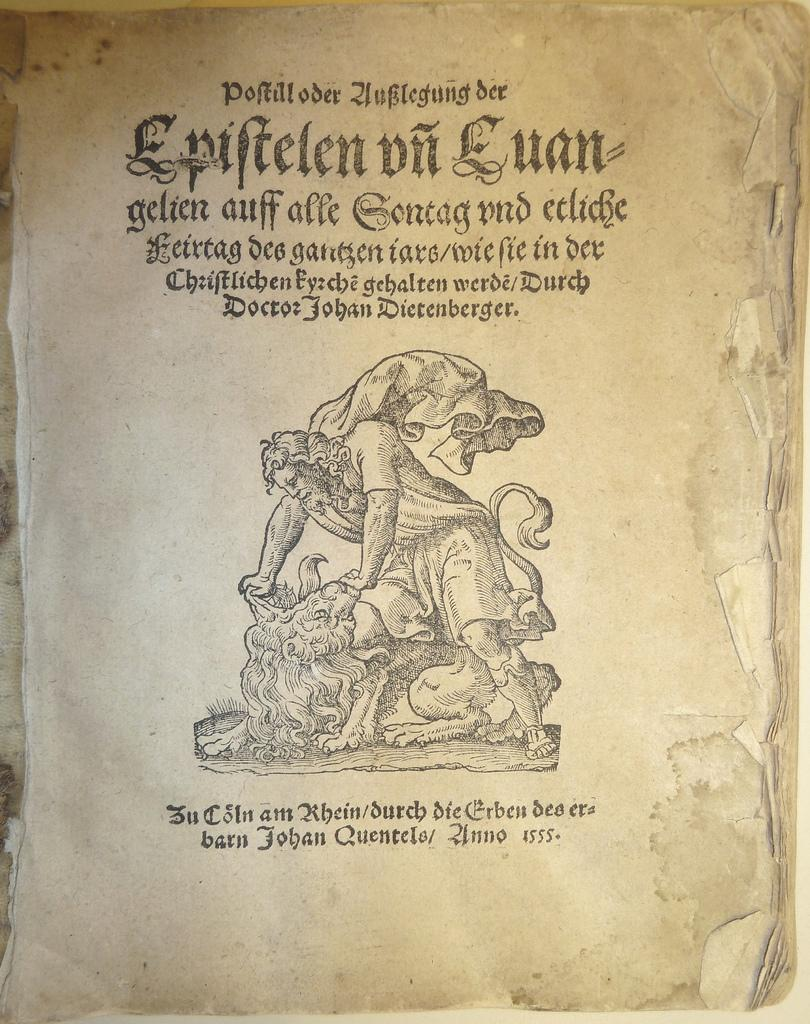<image>
Summarize the visual content of the image. a page with a picture on with words that say 'epiftelen un euan' on it 